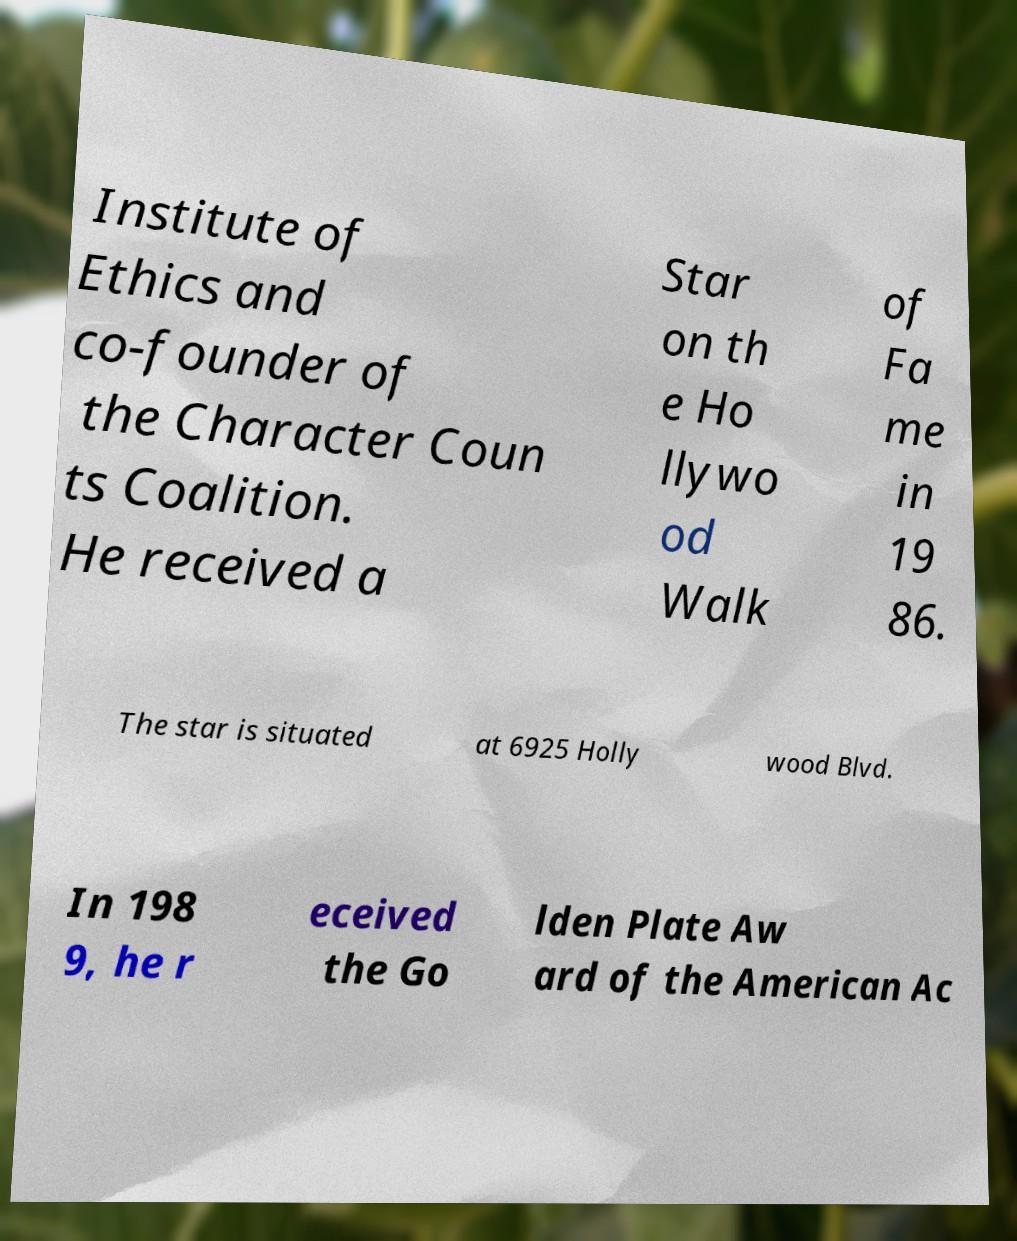What messages or text are displayed in this image? I need them in a readable, typed format. Institute of Ethics and co-founder of the Character Coun ts Coalition. He received a Star on th e Ho llywo od Walk of Fa me in 19 86. The star is situated at 6925 Holly wood Blvd. In 198 9, he r eceived the Go lden Plate Aw ard of the American Ac 